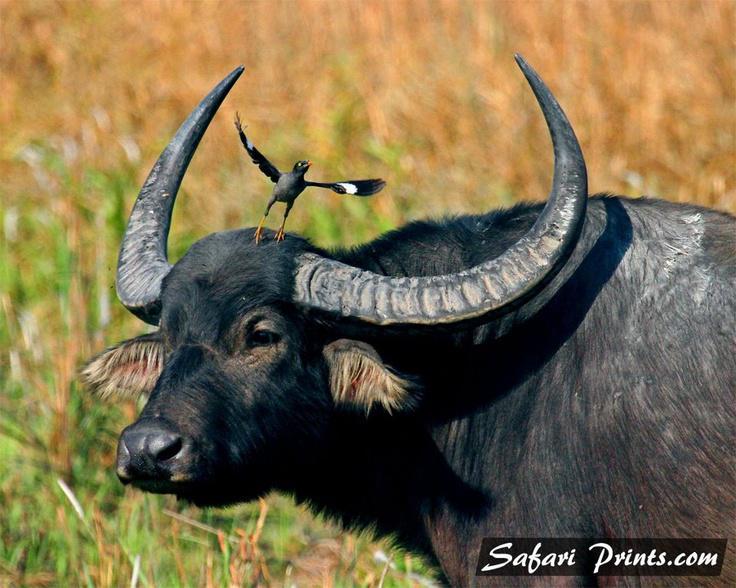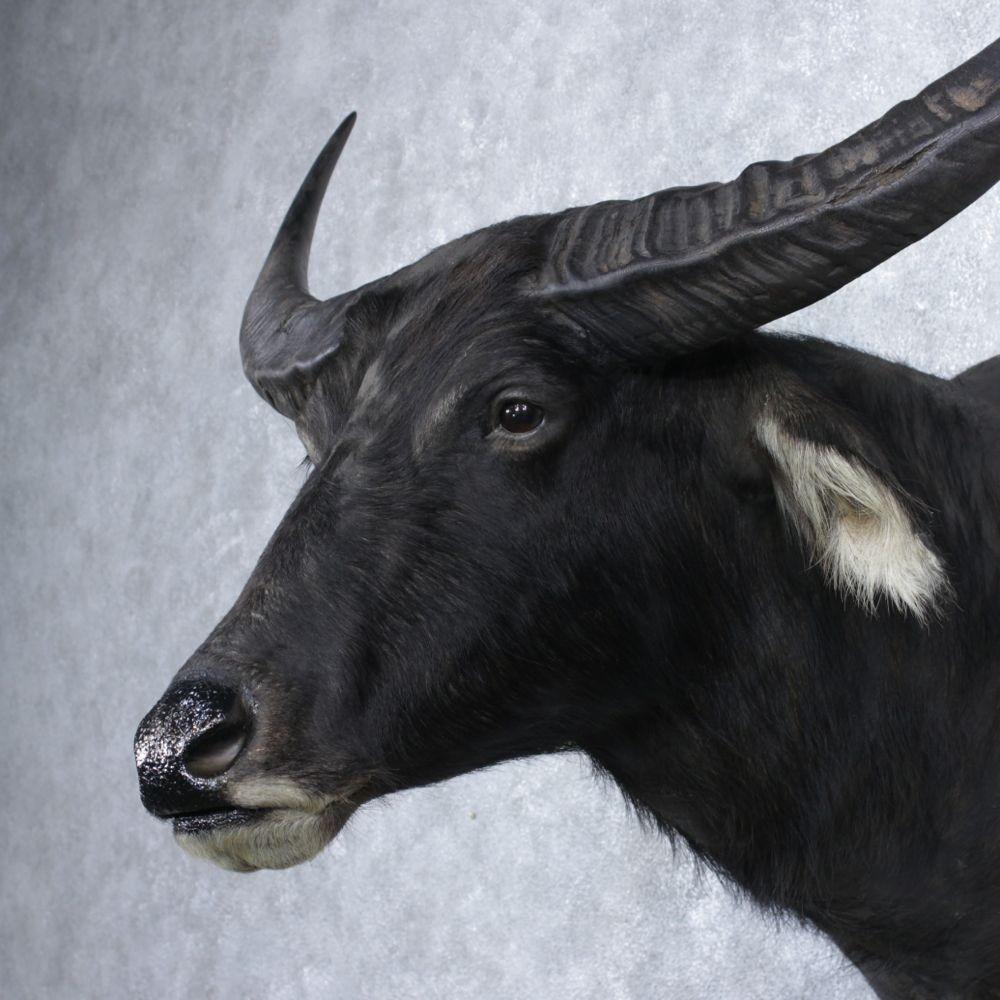The first image is the image on the left, the second image is the image on the right. Examine the images to the left and right. Is the description "There are three animals." accurate? Answer yes or no. Yes. The first image is the image on the left, the second image is the image on the right. For the images shown, is this caption "Each image includes one water buffalo who is looking straight ahead at the camera and who does not have a rope strung in its nose." true? Answer yes or no. No. 